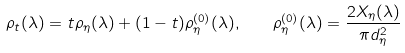Convert formula to latex. <formula><loc_0><loc_0><loc_500><loc_500>\rho _ { t } ( \lambda ) = t \rho _ { \eta } ( \lambda ) + ( 1 - t ) \rho ^ { ( 0 ) } _ { \eta } ( \lambda ) , \quad \rho ^ { ( 0 ) } _ { \eta } ( \lambda ) = \frac { 2 X _ { \eta } ( \lambda ) } { \pi d _ { \eta } ^ { 2 } }</formula> 